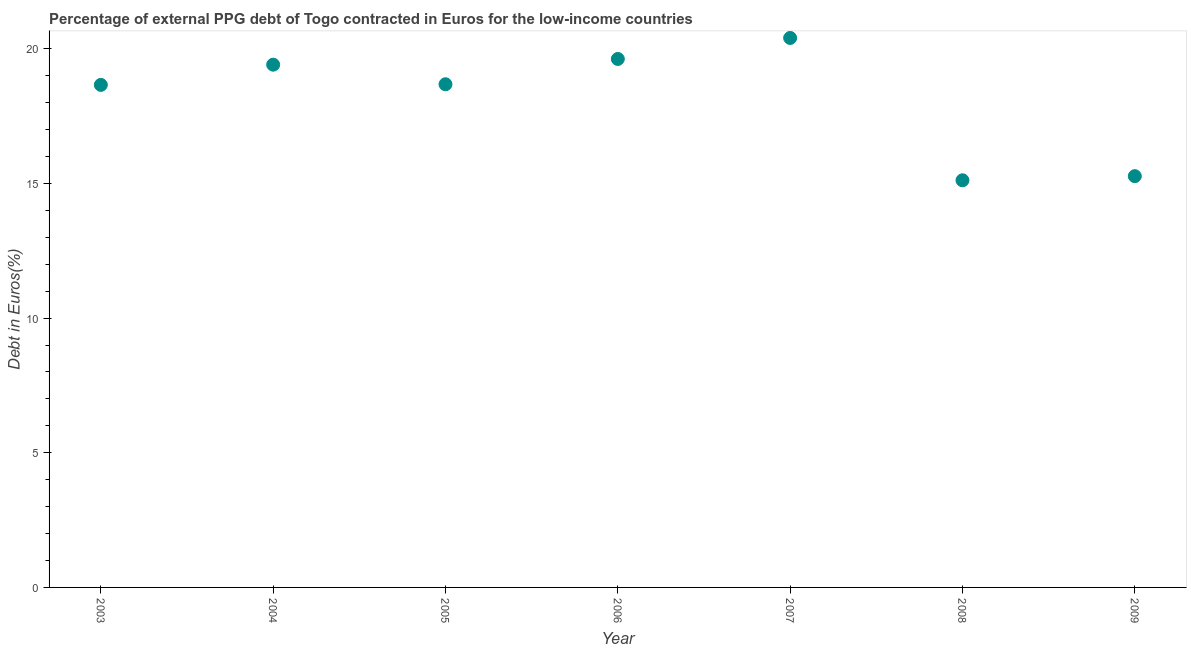What is the currency composition of ppg debt in 2003?
Offer a terse response. 18.66. Across all years, what is the maximum currency composition of ppg debt?
Provide a succinct answer. 20.4. Across all years, what is the minimum currency composition of ppg debt?
Offer a terse response. 15.12. In which year was the currency composition of ppg debt maximum?
Offer a very short reply. 2007. In which year was the currency composition of ppg debt minimum?
Offer a terse response. 2008. What is the sum of the currency composition of ppg debt?
Your answer should be compact. 127.16. What is the difference between the currency composition of ppg debt in 2005 and 2009?
Your answer should be compact. 3.41. What is the average currency composition of ppg debt per year?
Make the answer very short. 18.17. What is the median currency composition of ppg debt?
Make the answer very short. 18.68. What is the ratio of the currency composition of ppg debt in 2005 to that in 2006?
Your answer should be compact. 0.95. Is the difference between the currency composition of ppg debt in 2004 and 2009 greater than the difference between any two years?
Ensure brevity in your answer.  No. What is the difference between the highest and the second highest currency composition of ppg debt?
Your answer should be very brief. 0.78. What is the difference between the highest and the lowest currency composition of ppg debt?
Provide a short and direct response. 5.28. In how many years, is the currency composition of ppg debt greater than the average currency composition of ppg debt taken over all years?
Keep it short and to the point. 5. Does the graph contain any zero values?
Your answer should be very brief. No. Does the graph contain grids?
Give a very brief answer. No. What is the title of the graph?
Your answer should be very brief. Percentage of external PPG debt of Togo contracted in Euros for the low-income countries. What is the label or title of the Y-axis?
Provide a succinct answer. Debt in Euros(%). What is the Debt in Euros(%) in 2003?
Give a very brief answer. 18.66. What is the Debt in Euros(%) in 2004?
Provide a short and direct response. 19.41. What is the Debt in Euros(%) in 2005?
Your answer should be compact. 18.68. What is the Debt in Euros(%) in 2006?
Your answer should be very brief. 19.62. What is the Debt in Euros(%) in 2007?
Your answer should be very brief. 20.4. What is the Debt in Euros(%) in 2008?
Your answer should be very brief. 15.12. What is the Debt in Euros(%) in 2009?
Offer a very short reply. 15.27. What is the difference between the Debt in Euros(%) in 2003 and 2004?
Keep it short and to the point. -0.75. What is the difference between the Debt in Euros(%) in 2003 and 2005?
Your answer should be compact. -0.02. What is the difference between the Debt in Euros(%) in 2003 and 2006?
Offer a terse response. -0.96. What is the difference between the Debt in Euros(%) in 2003 and 2007?
Your answer should be very brief. -1.74. What is the difference between the Debt in Euros(%) in 2003 and 2008?
Provide a succinct answer. 3.54. What is the difference between the Debt in Euros(%) in 2003 and 2009?
Provide a short and direct response. 3.39. What is the difference between the Debt in Euros(%) in 2004 and 2005?
Keep it short and to the point. 0.73. What is the difference between the Debt in Euros(%) in 2004 and 2006?
Ensure brevity in your answer.  -0.21. What is the difference between the Debt in Euros(%) in 2004 and 2007?
Give a very brief answer. -0.99. What is the difference between the Debt in Euros(%) in 2004 and 2008?
Your answer should be compact. 4.29. What is the difference between the Debt in Euros(%) in 2004 and 2009?
Provide a succinct answer. 4.14. What is the difference between the Debt in Euros(%) in 2005 and 2006?
Your response must be concise. -0.94. What is the difference between the Debt in Euros(%) in 2005 and 2007?
Offer a very short reply. -1.72. What is the difference between the Debt in Euros(%) in 2005 and 2008?
Offer a terse response. 3.57. What is the difference between the Debt in Euros(%) in 2005 and 2009?
Ensure brevity in your answer.  3.41. What is the difference between the Debt in Euros(%) in 2006 and 2007?
Ensure brevity in your answer.  -0.78. What is the difference between the Debt in Euros(%) in 2006 and 2008?
Your response must be concise. 4.5. What is the difference between the Debt in Euros(%) in 2006 and 2009?
Offer a terse response. 4.35. What is the difference between the Debt in Euros(%) in 2007 and 2008?
Ensure brevity in your answer.  5.28. What is the difference between the Debt in Euros(%) in 2007 and 2009?
Give a very brief answer. 5.13. What is the difference between the Debt in Euros(%) in 2008 and 2009?
Offer a very short reply. -0.15. What is the ratio of the Debt in Euros(%) in 2003 to that in 2004?
Your answer should be very brief. 0.96. What is the ratio of the Debt in Euros(%) in 2003 to that in 2006?
Your answer should be compact. 0.95. What is the ratio of the Debt in Euros(%) in 2003 to that in 2007?
Make the answer very short. 0.92. What is the ratio of the Debt in Euros(%) in 2003 to that in 2008?
Give a very brief answer. 1.23. What is the ratio of the Debt in Euros(%) in 2003 to that in 2009?
Keep it short and to the point. 1.22. What is the ratio of the Debt in Euros(%) in 2004 to that in 2005?
Your response must be concise. 1.04. What is the ratio of the Debt in Euros(%) in 2004 to that in 2007?
Your response must be concise. 0.95. What is the ratio of the Debt in Euros(%) in 2004 to that in 2008?
Give a very brief answer. 1.28. What is the ratio of the Debt in Euros(%) in 2004 to that in 2009?
Make the answer very short. 1.27. What is the ratio of the Debt in Euros(%) in 2005 to that in 2006?
Keep it short and to the point. 0.95. What is the ratio of the Debt in Euros(%) in 2005 to that in 2007?
Your answer should be compact. 0.92. What is the ratio of the Debt in Euros(%) in 2005 to that in 2008?
Your answer should be very brief. 1.24. What is the ratio of the Debt in Euros(%) in 2005 to that in 2009?
Offer a terse response. 1.22. What is the ratio of the Debt in Euros(%) in 2006 to that in 2008?
Make the answer very short. 1.3. What is the ratio of the Debt in Euros(%) in 2006 to that in 2009?
Your answer should be compact. 1.28. What is the ratio of the Debt in Euros(%) in 2007 to that in 2008?
Provide a short and direct response. 1.35. What is the ratio of the Debt in Euros(%) in 2007 to that in 2009?
Your answer should be very brief. 1.34. 